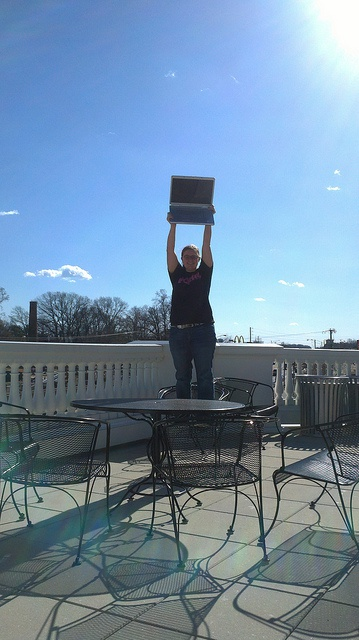Describe the objects in this image and their specific colors. I can see chair in gray, black, and darkgray tones, chair in gray, black, purple, and darkgray tones, people in gray, black, and purple tones, chair in gray, black, darkgray, and purple tones, and dining table in gray, black, and blue tones in this image. 